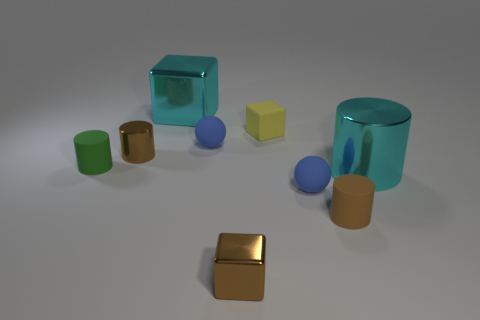Subtract 1 cylinders. How many cylinders are left? 3 Subtract all green cylinders. Subtract all cyan balls. How many cylinders are left? 3 Subtract all cylinders. How many objects are left? 5 Add 6 brown things. How many brown things exist? 9 Subtract 0 red cylinders. How many objects are left? 9 Subtract all small blue things. Subtract all small matte cylinders. How many objects are left? 5 Add 2 tiny green cylinders. How many tiny green cylinders are left? 3 